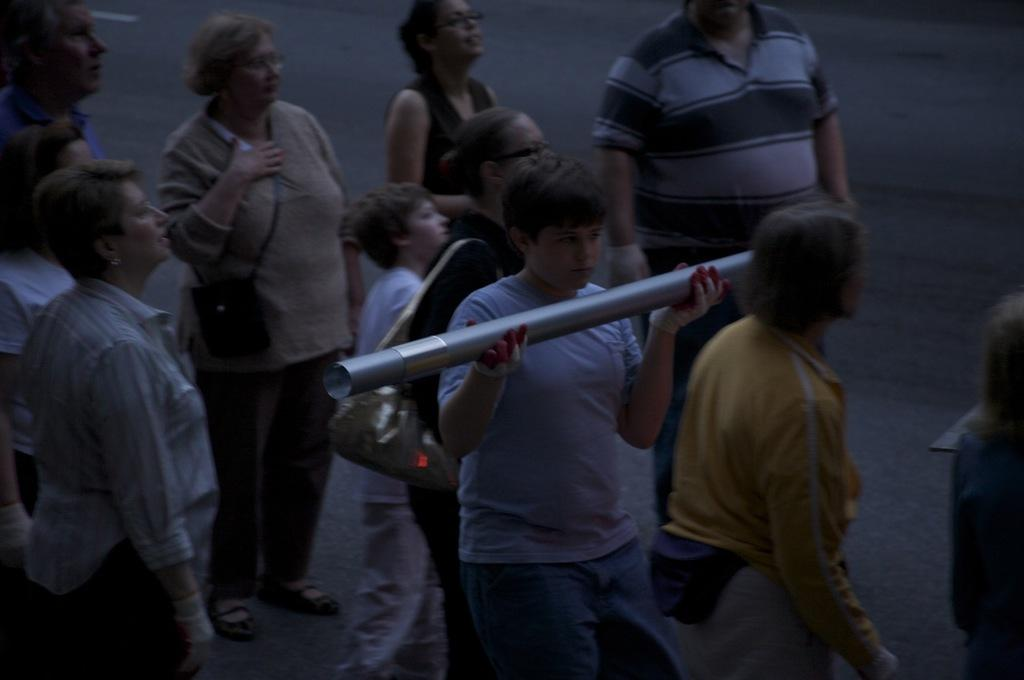How many people are in the group shown in the image? There is a group of people in the image. What are some people in the group wearing? Some people in the group are wearing bags. Can you describe the position of the man in the image? There is a man in the middle of the image. What is the man holding in the image? The man is holding a pipe. What type of harmony is being played by the group in the image? There is no indication of music or harmony being played in the image. Can you tell me the name of the man's sister in the image? There is no mention of a sister or any family members in the image. 